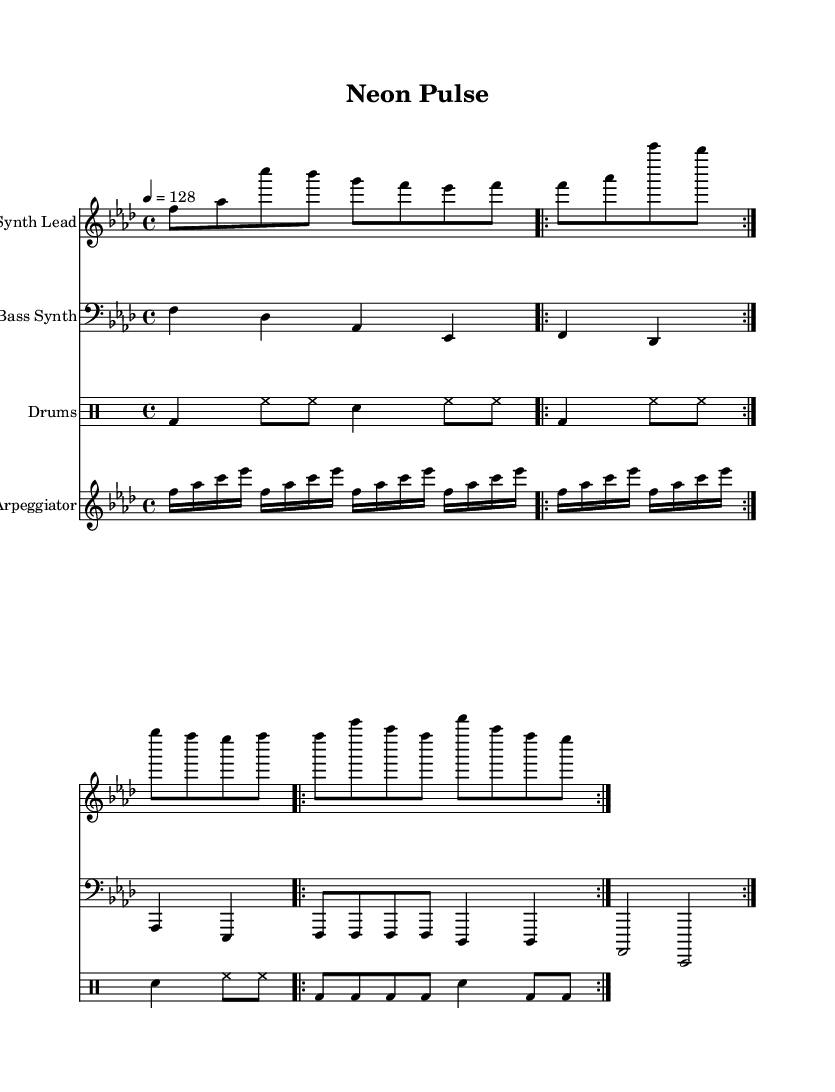What is the key signature of this music? The key signature is F minor, which includes four flats: B-flat, E-flat, A-flat, and D-flat.
Answer: F minor What is the time signature of this music? The time signature is indicated at the beginning and shows that there are four beats in each measure, making it 4/4.
Answer: 4/4 What is the tempo marking for this piece? The tempo marking indicates that the piece is to be played at a speed of 128 beats per minute, which is typical for high-energy EDM.
Answer: 128 Which instrument plays the bass line? The bass line in this sheet music is stated to be played by the "Bass Synth," which is indicated both in the staff name and the melody context.
Answer: Bass Synth How many times is the drum pattern repeated? The drum pattern is indicated to repeat twice, which can be determined from the “\repeat volta 2” in its notation.
Answer: 2 Which instrument plays the lead melody? The lead melody is played by the "Synth Lead," which is clearly labeled at the start of its staff.
Answer: Synth Lead Why is the bass line important in this EDM piece? The bass line, particularly with its heavy bass drops as indicated in the music, provides the foundation and energy essential for peak hour sets in EDM, making the music feel driving and dynamic.
Answer: Foundation and energy 